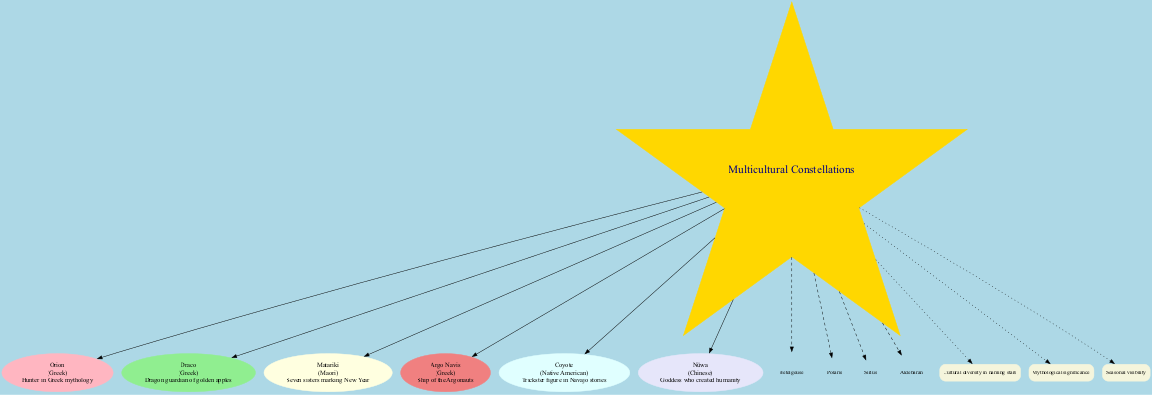What is the name of the constellation representing a hunter in Greek mythology? The diagram contains a constellation labeled 'Orion', which is explicitly stated to represent a hunter in Greek mythology.
Answer: Orion How many constellations are depicted in the diagram? By counting the nodes labeled under 'constellations', we find there are a total of six different constellations illustrated in the diagram.
Answer: 6 Which culture is associated with the constellation Matariki? The diagram pairs the constellation 'Matariki' with the culture 'Maori', clearly indicating that this particular constellation is associated with Maori culture.
Answer: Maori What does the constellation Coyote represent in Native American stories? The diagram describes 'Coyote' as a trickster figure in Navajo stories, which directly answers the question regarding what this constellation represents.
Answer: Trickster Name one connection theme demonstrated in the diagram. The diagram includes a theme labeled 'Cultural diversity in naming stars', denoting one of the connection aspects that relate several elements shown in the diagram.
Answer: Cultural diversity in naming stars Which celestial object is listed in the diagram that is also known for being one of the brightest stars in Earth's night sky? The list of celestial objects includes 'Sirius', which is renowned as one of the brightest stars visible from Earth, and this is directly stated in the diagram.
Answer: Sirius Which constellation in the diagram is associated with a goddess who created humanity? Based on the information in the constellation nodes, 'Nüwa' is indicated as the goddess who created humanity, making it the specific answer to this inquiry.
Answer: Nüwa What is the overall theme centered in the diagram? The title of the central node is marked 'Multicultural Constellations', which indicates that the entire diagram revolves around this central theme, tying together various cultural contributions.
Answer: Multicultural Constellations 